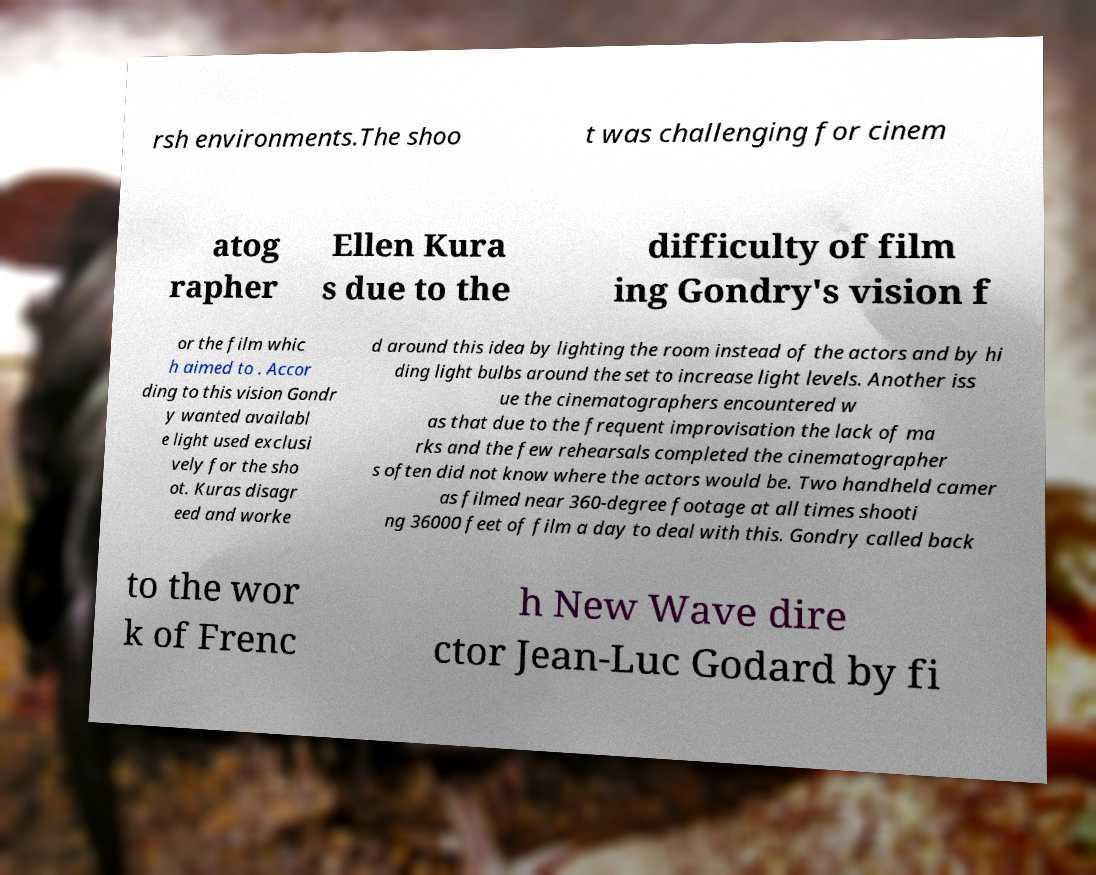For documentation purposes, I need the text within this image transcribed. Could you provide that? rsh environments.The shoo t was challenging for cinem atog rapher Ellen Kura s due to the difficulty of film ing Gondry's vision f or the film whic h aimed to . Accor ding to this vision Gondr y wanted availabl e light used exclusi vely for the sho ot. Kuras disagr eed and worke d around this idea by lighting the room instead of the actors and by hi ding light bulbs around the set to increase light levels. Another iss ue the cinematographers encountered w as that due to the frequent improvisation the lack of ma rks and the few rehearsals completed the cinematographer s often did not know where the actors would be. Two handheld camer as filmed near 360-degree footage at all times shooti ng 36000 feet of film a day to deal with this. Gondry called back to the wor k of Frenc h New Wave dire ctor Jean-Luc Godard by fi 